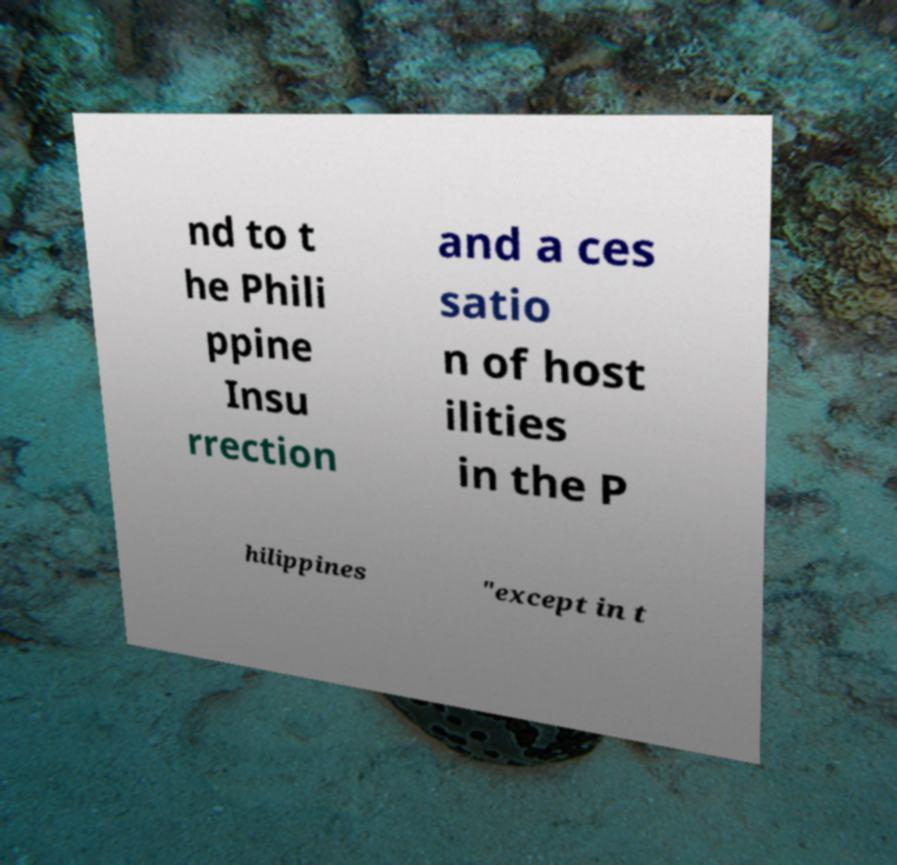I need the written content from this picture converted into text. Can you do that? nd to t he Phili ppine Insu rrection and a ces satio n of host ilities in the P hilippines "except in t 